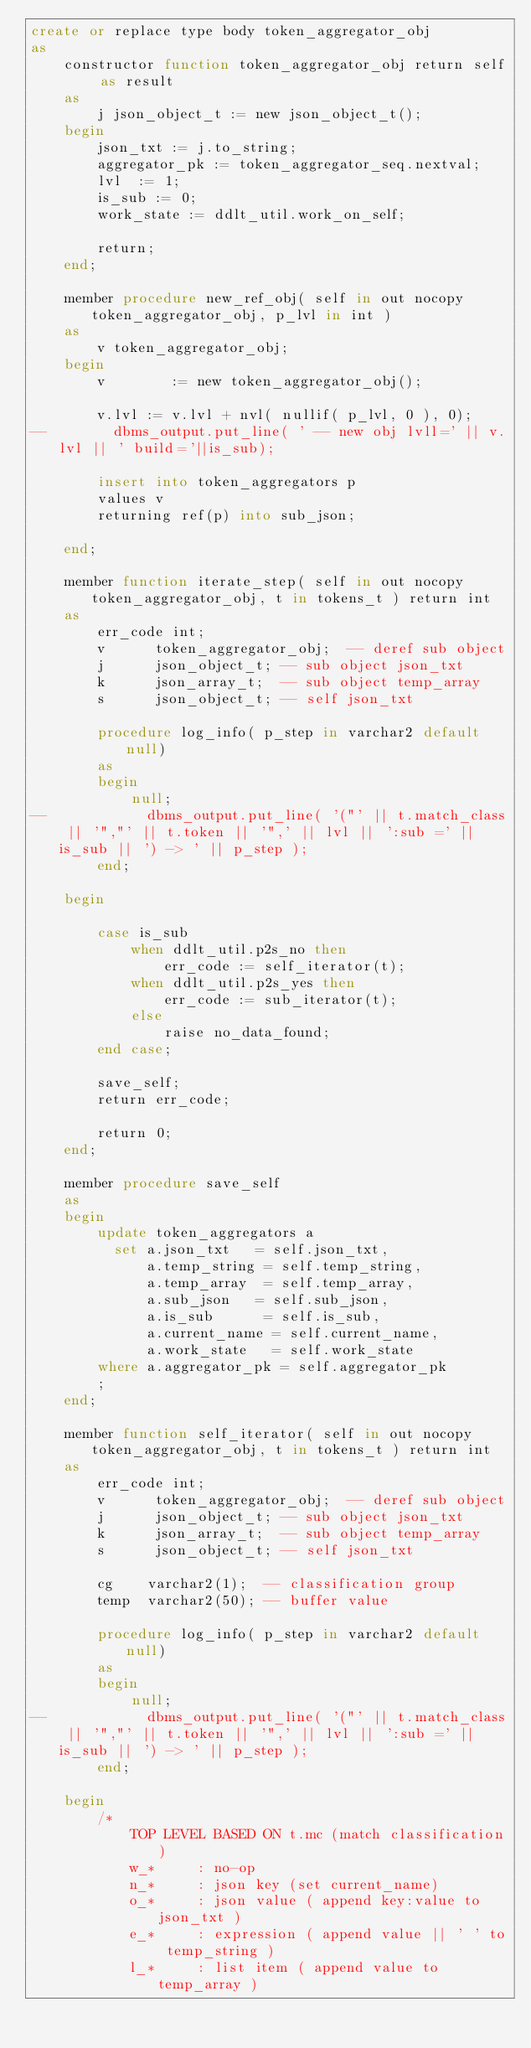Convert code to text. <code><loc_0><loc_0><loc_500><loc_500><_SQL_>create or replace type body token_aggregator_obj
as
    constructor function token_aggregator_obj return self as result
    as
        j json_object_t := new json_object_t();
    begin
        json_txt := j.to_string;
        aggregator_pk := token_aggregator_seq.nextval;
        lvl  := 1;
        is_sub := 0;
        work_state := ddlt_util.work_on_self;

        return;
    end;

    member procedure new_ref_obj( self in out nocopy token_aggregator_obj, p_lvl in int )
    as
        v token_aggregator_obj;
    begin
        v        := new token_aggregator_obj();

        v.lvl := v.lvl + nvl( nullif( p_lvl, 0 ), 0);
--        dbms_output.put_line( ' -- new obj lvll=' || v.lvl || ' build='||is_sub);

        insert into token_aggregators p
        values v
        returning ref(p) into sub_json;

    end;

    member function iterate_step( self in out nocopy token_aggregator_obj, t in tokens_t ) return int
    as
        err_code int;
        v      token_aggregator_obj;  -- deref sub object
        j      json_object_t; -- sub object json_txt
        k      json_array_t;  -- sub object temp_array
        s      json_object_t; -- self json_txt

        procedure log_info( p_step in varchar2 default null)
        as
        begin
            null;
--            dbms_output.put_line( '("' || t.match_class || '","' || t.token || '",' || lvl || ':sub =' || is_sub || ') -> ' || p_step );
        end;

    begin

        case is_sub
            when ddlt_util.p2s_no then
                err_code := self_iterator(t);
            when ddlt_util.p2s_yes then
                err_code := sub_iterator(t);
            else
                raise no_data_found;
        end case;

        save_self;
        return err_code;

        return 0;
    end;

    member procedure save_self
    as
    begin
        update token_aggregators a
          set a.json_txt   = self.json_txt,
              a.temp_string = self.temp_string,
              a.temp_array  = self.temp_array,
              a.sub_json   = self.sub_json,
              a.is_sub      = self.is_sub,
              a.current_name = self.current_name,
              a.work_state   = self.work_state
        where a.aggregator_pk = self.aggregator_pk
        ;
    end;

    member function self_iterator( self in out nocopy token_aggregator_obj, t in tokens_t ) return int
    as
        err_code int;
        v      token_aggregator_obj;  -- deref sub object
        j      json_object_t; -- sub object json_txt
        k      json_array_t;  -- sub object temp_array
        s      json_object_t; -- self json_txt

        cg    varchar2(1);  -- classification group
        temp  varchar2(50); -- buffer value

        procedure log_info( p_step in varchar2 default null)
        as
        begin
            null;
--            dbms_output.put_line( '("' || t.match_class || '","' || t.token || '",' || lvl || ':sub =' || is_sub || ') -> ' || p_step );
        end;

    begin
        /*
            TOP LEVEL BASED ON t.mc (match classification)
            w_*     : no-op
            n_*     : json key (set current_name)
            o_*     : json value ( append key:value to json_txt )
            e_*     : expression ( append value || ' ' to temp_string )
            l_*     : list item ( append value to temp_array )</code> 